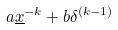<formula> <loc_0><loc_0><loc_500><loc_500>a \underline { x } ^ { - k } + b \delta ^ { ( k - 1 ) }</formula> 